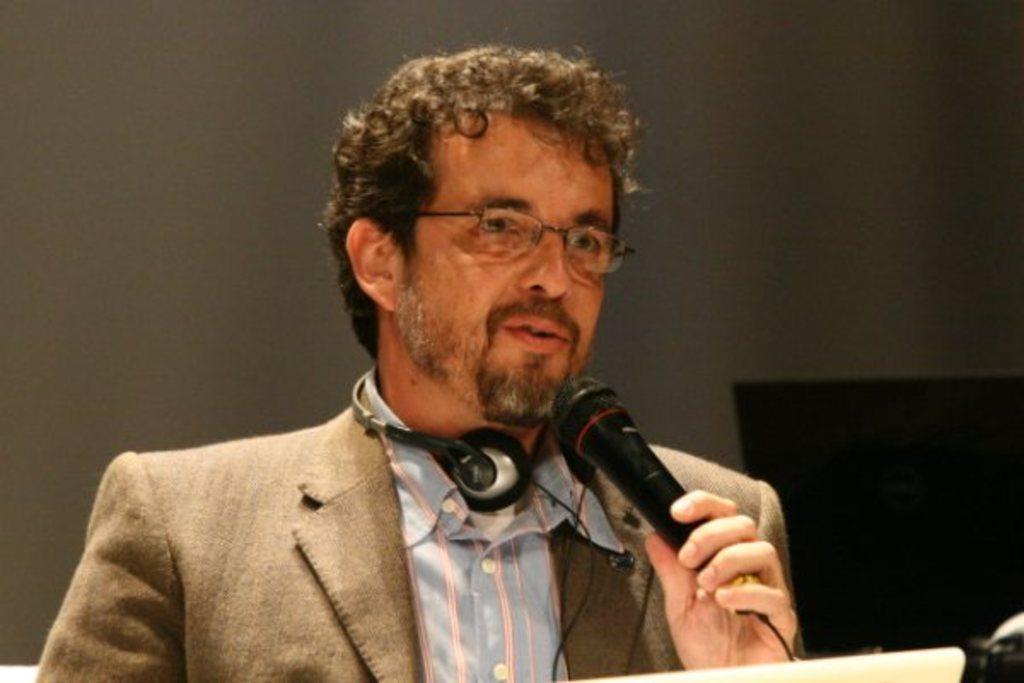Please provide a concise description of this image. In this image there is a man holding a microphone and talking , in the back ground there is a wall. 